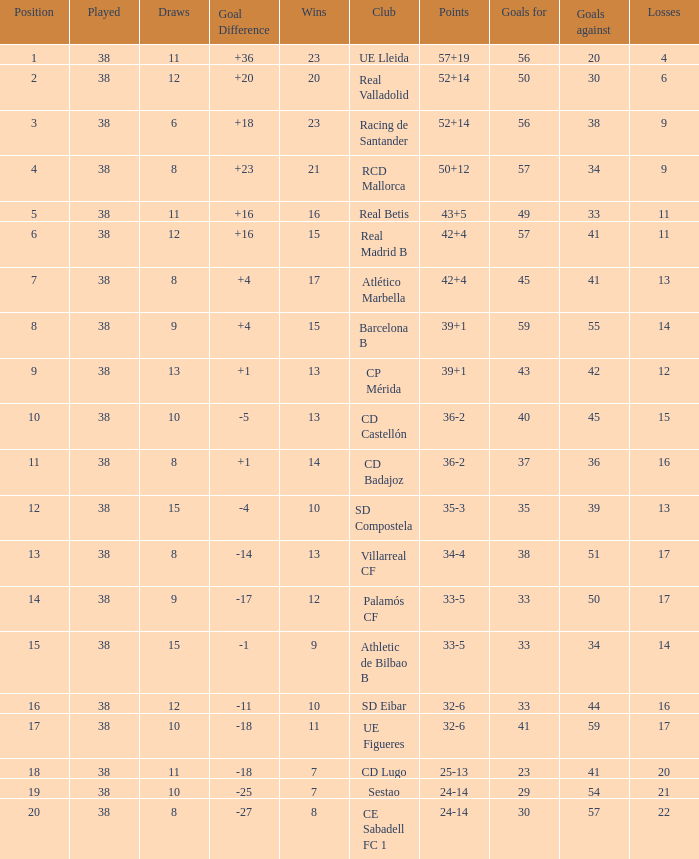What is the highest number played with a goal difference less than -27? None. 